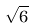Convert formula to latex. <formula><loc_0><loc_0><loc_500><loc_500>\sqrt { 6 }</formula> 